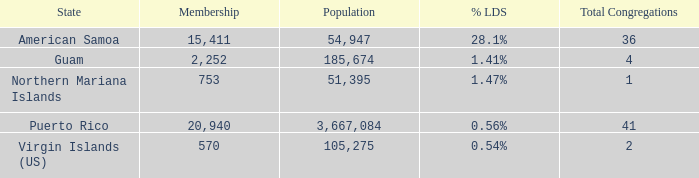54% and population is more than 105,275? 0.0. 